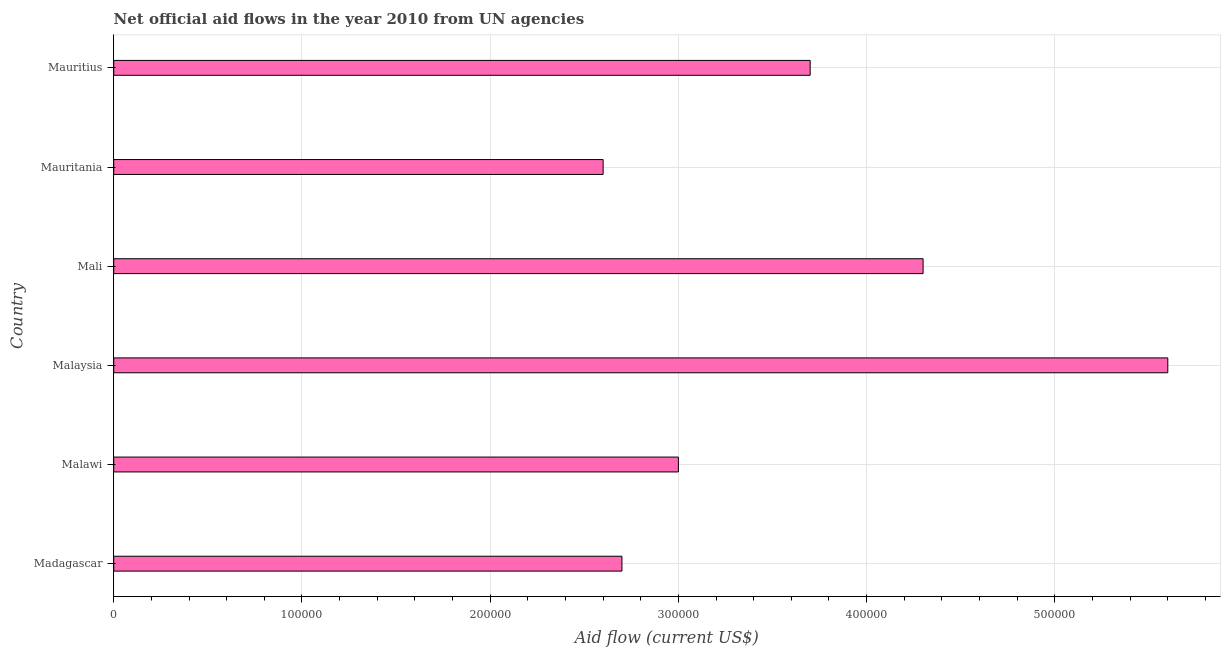Does the graph contain any zero values?
Provide a succinct answer. No. Does the graph contain grids?
Provide a short and direct response. Yes. What is the title of the graph?
Provide a succinct answer. Net official aid flows in the year 2010 from UN agencies. What is the label or title of the Y-axis?
Offer a very short reply. Country. What is the net official flows from un agencies in Malaysia?
Your answer should be compact. 5.60e+05. Across all countries, what is the maximum net official flows from un agencies?
Offer a very short reply. 5.60e+05. Across all countries, what is the minimum net official flows from un agencies?
Provide a short and direct response. 2.60e+05. In which country was the net official flows from un agencies maximum?
Ensure brevity in your answer.  Malaysia. In which country was the net official flows from un agencies minimum?
Provide a short and direct response. Mauritania. What is the sum of the net official flows from un agencies?
Provide a succinct answer. 2.19e+06. What is the difference between the net official flows from un agencies in Madagascar and Mali?
Provide a short and direct response. -1.60e+05. What is the average net official flows from un agencies per country?
Offer a terse response. 3.65e+05. What is the median net official flows from un agencies?
Provide a succinct answer. 3.35e+05. In how many countries, is the net official flows from un agencies greater than 100000 US$?
Ensure brevity in your answer.  6. What is the ratio of the net official flows from un agencies in Malawi to that in Malaysia?
Ensure brevity in your answer.  0.54. Is the net official flows from un agencies in Malawi less than that in Malaysia?
Keep it short and to the point. Yes. What is the difference between the highest and the lowest net official flows from un agencies?
Give a very brief answer. 3.00e+05. How many bars are there?
Offer a terse response. 6. Are all the bars in the graph horizontal?
Give a very brief answer. Yes. How many countries are there in the graph?
Provide a short and direct response. 6. What is the difference between two consecutive major ticks on the X-axis?
Your answer should be compact. 1.00e+05. What is the Aid flow (current US$) of Madagascar?
Give a very brief answer. 2.70e+05. What is the Aid flow (current US$) of Malaysia?
Your answer should be very brief. 5.60e+05. What is the difference between the Aid flow (current US$) in Madagascar and Malaysia?
Your answer should be very brief. -2.90e+05. What is the difference between the Aid flow (current US$) in Madagascar and Mali?
Offer a terse response. -1.60e+05. What is the difference between the Aid flow (current US$) in Malawi and Malaysia?
Provide a succinct answer. -2.60e+05. What is the difference between the Aid flow (current US$) in Malawi and Mauritania?
Ensure brevity in your answer.  4.00e+04. What is the difference between the Aid flow (current US$) in Malaysia and Mali?
Offer a terse response. 1.30e+05. What is the difference between the Aid flow (current US$) in Malaysia and Mauritius?
Keep it short and to the point. 1.90e+05. What is the difference between the Aid flow (current US$) in Mali and Mauritania?
Ensure brevity in your answer.  1.70e+05. What is the difference between the Aid flow (current US$) in Mali and Mauritius?
Your answer should be compact. 6.00e+04. What is the ratio of the Aid flow (current US$) in Madagascar to that in Malawi?
Ensure brevity in your answer.  0.9. What is the ratio of the Aid flow (current US$) in Madagascar to that in Malaysia?
Your response must be concise. 0.48. What is the ratio of the Aid flow (current US$) in Madagascar to that in Mali?
Keep it short and to the point. 0.63. What is the ratio of the Aid flow (current US$) in Madagascar to that in Mauritania?
Provide a short and direct response. 1.04. What is the ratio of the Aid flow (current US$) in Madagascar to that in Mauritius?
Your answer should be very brief. 0.73. What is the ratio of the Aid flow (current US$) in Malawi to that in Malaysia?
Make the answer very short. 0.54. What is the ratio of the Aid flow (current US$) in Malawi to that in Mali?
Provide a short and direct response. 0.7. What is the ratio of the Aid flow (current US$) in Malawi to that in Mauritania?
Your response must be concise. 1.15. What is the ratio of the Aid flow (current US$) in Malawi to that in Mauritius?
Your answer should be compact. 0.81. What is the ratio of the Aid flow (current US$) in Malaysia to that in Mali?
Give a very brief answer. 1.3. What is the ratio of the Aid flow (current US$) in Malaysia to that in Mauritania?
Make the answer very short. 2.15. What is the ratio of the Aid flow (current US$) in Malaysia to that in Mauritius?
Your answer should be compact. 1.51. What is the ratio of the Aid flow (current US$) in Mali to that in Mauritania?
Your answer should be compact. 1.65. What is the ratio of the Aid flow (current US$) in Mali to that in Mauritius?
Your answer should be compact. 1.16. What is the ratio of the Aid flow (current US$) in Mauritania to that in Mauritius?
Your answer should be very brief. 0.7. 